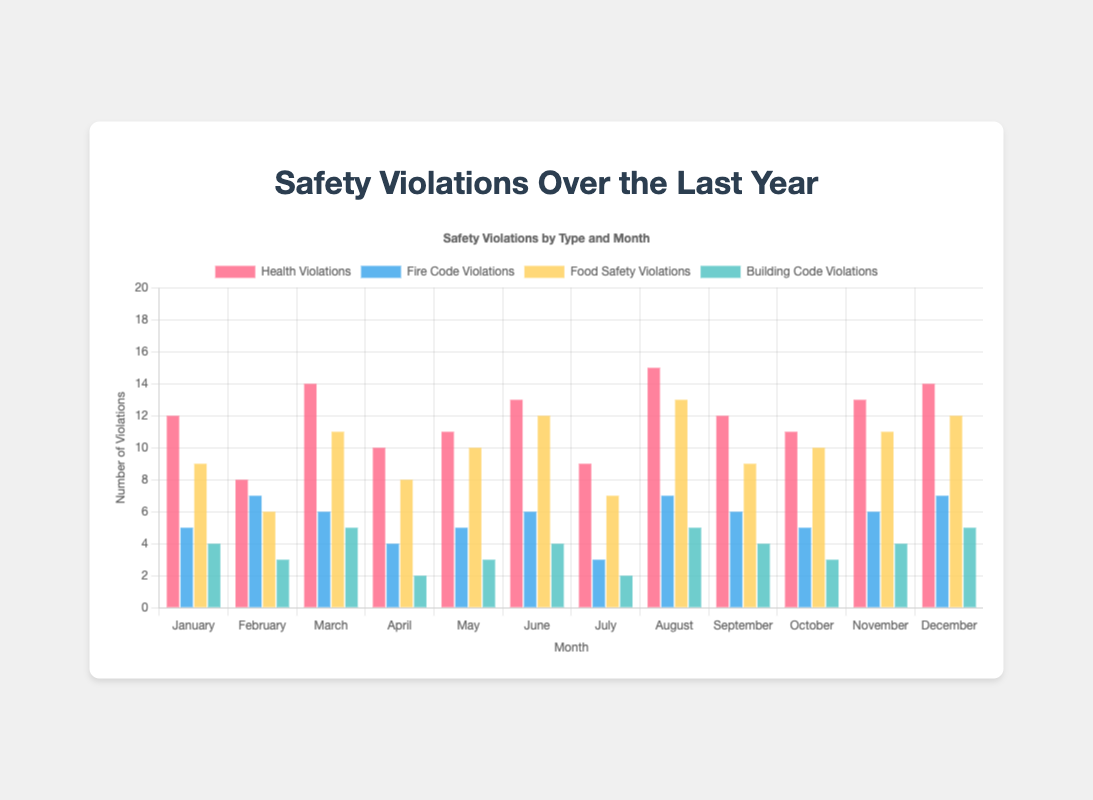Which month had the highest number of health violations? To identify the month with the highest number of health violations, look at the 'Health Violations' bars across all months and find the tallest bar.
Answer: August During which month(s) did fire code and food safety violations have the same count? Check the bars representing 'Fire Code Violations' and 'Food Safety Violations' for each month. Look for months where the heights of these bars are equal.
Answer: February, July, September, October Which type of violation had the highest total instances over the year? Sum the monthly counts for each type of violation over the year and compare the totals. 'Health Violations': 142, 'Fire Code Violations': 66, 'Food Safety Violations': 118, 'Building Code Violations': 44.
Answer: Health Violations How many total violations occurred in June? Sum all types of violations in June: Health Violations (13) + Fire Code Violations (6) + Food Safety Violations (12) + Building Code Violations (4).
Answer: 35 Which month had the least total violations? Sum all types of violations for each month and find the month with the smallest total sum. January (30), February (24), March (36), April (24), May (29), June (35), July (21), August (40), September (31), October (29), November (34), December (38).
Answer: July How do the health violations in March compare to those in May? Compare the heights of the 'Health Violations' bars for March (14) and May (11).
Answer: March has more violations What's the difference in the number of fire code violations between the months with the highest and lowest counts? Identify the months with the highest (February, August, December: 7) and lowest (July: 3) counts and calculate the difference: 7 - 3 = 4.
Answer: 4 Which months had an equal number of building code violations? Compare the 'Building Code Violations' bar heights for each month and find those with equal heights. January, June, September, November (4 each); February, April, July, October (3 each).
Answer: January, June, September, November; February, April, July, October What is the average number of food safety violations per month? Sum the monthly 'Food Safety Violations' (9+6+11+8+10+12+7+13+9+10+11+12) and divide by 12. Sum = 118, Average = 118/12 ≈ 9.83.
Answer: 9.83 What is the sum of all health and food safety violations in December? Add health violations (14) and food safety violations (12) for December: 14 + 12 = 26.
Answer: 26 